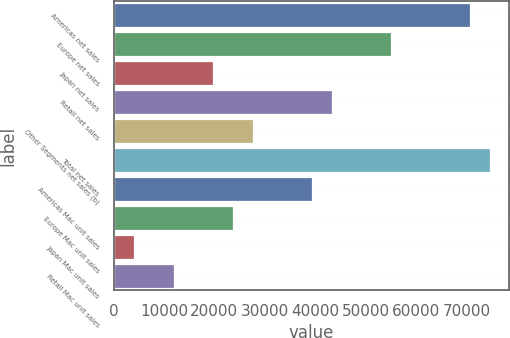Convert chart. <chart><loc_0><loc_0><loc_500><loc_500><bar_chart><fcel>Americas net sales<fcel>Europe net sales<fcel>Japan net sales<fcel>Retail net sales<fcel>Other Segments net sales (b)<fcel>Total net sales<fcel>Americas Mac unit sales<fcel>Europe Mac unit sales<fcel>Japan Mac unit sales<fcel>Retail Mac unit sales<nl><fcel>70780.2<fcel>55094.6<fcel>19802<fcel>43330.4<fcel>27644.8<fcel>74701.6<fcel>39409<fcel>23723.4<fcel>4116.4<fcel>11959.2<nl></chart> 